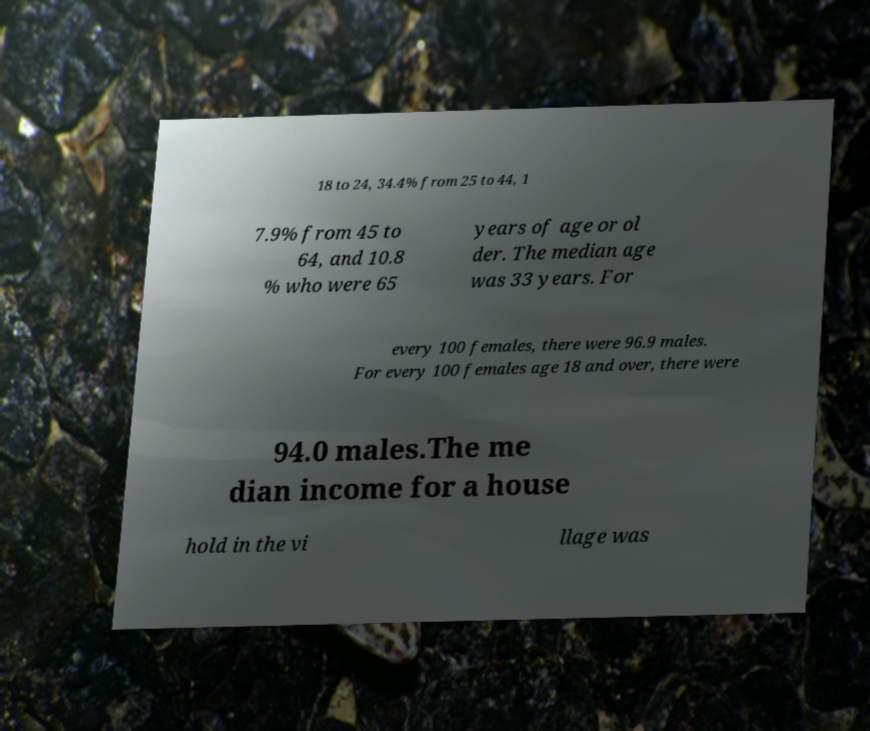What messages or text are displayed in this image? I need them in a readable, typed format. 18 to 24, 34.4% from 25 to 44, 1 7.9% from 45 to 64, and 10.8 % who were 65 years of age or ol der. The median age was 33 years. For every 100 females, there were 96.9 males. For every 100 females age 18 and over, there were 94.0 males.The me dian income for a house hold in the vi llage was 